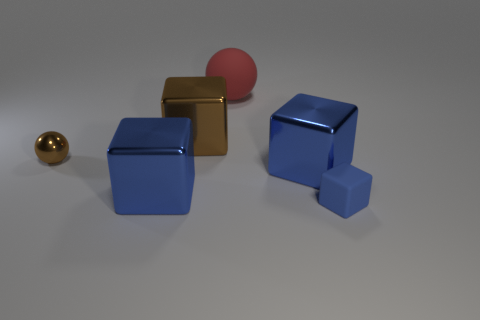Are there any big metallic objects of the same color as the small sphere?
Ensure brevity in your answer.  Yes. Are there any other things that are the same color as the tiny matte object?
Provide a succinct answer. Yes. The brown metallic thing to the right of the metal cube that is in front of the large metallic cube that is on the right side of the red ball is what shape?
Your response must be concise. Cube. The big object to the right of the large sphere is what color?
Give a very brief answer. Blue. How many things are brown objects that are in front of the brown metallic cube or blue objects that are on the right side of the brown metal block?
Provide a short and direct response. 3. What number of big red objects have the same shape as the tiny blue matte thing?
Ensure brevity in your answer.  0. What is the color of the matte cube that is the same size as the brown metal ball?
Provide a short and direct response. Blue. What is the color of the small thing in front of the small thing left of the blue rubber thing that is to the right of the tiny brown metal object?
Ensure brevity in your answer.  Blue. Do the red rubber thing and the rubber object that is in front of the small brown metal ball have the same size?
Make the answer very short. No. What number of objects are tiny green rubber cylinders or metal balls?
Your answer should be compact. 1. 